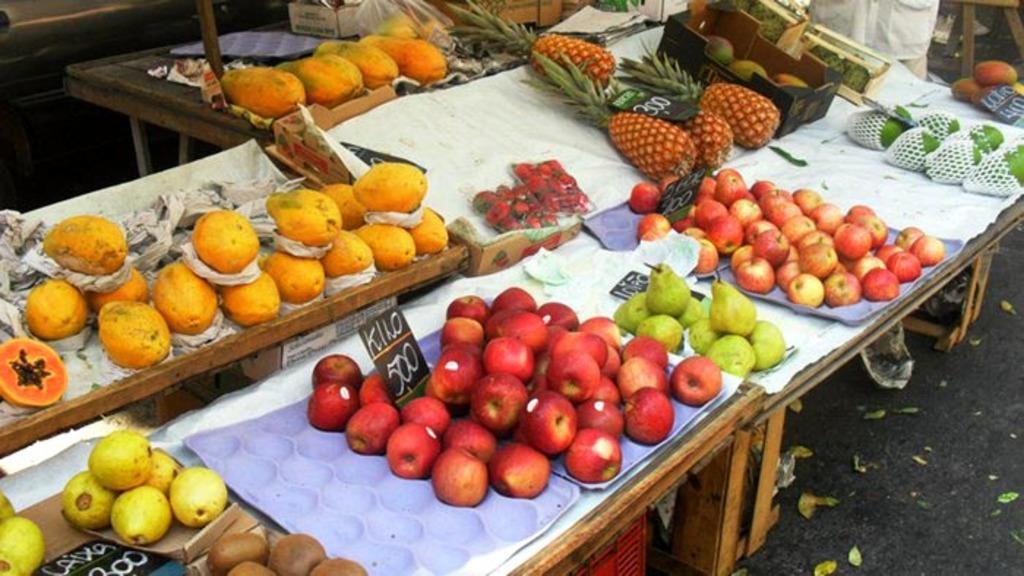How would you summarize this image in a sentence or two? In this picture we can see few fruits on the table, in the background we can find a person and a plastic bag. 